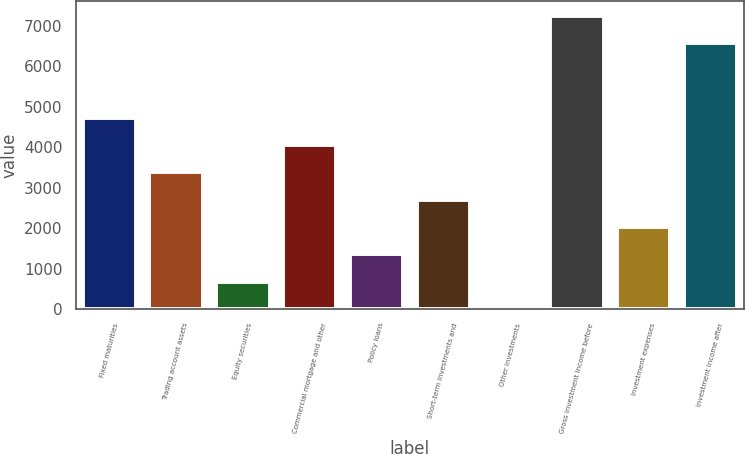<chart> <loc_0><loc_0><loc_500><loc_500><bar_chart><fcel>Fixed maturities<fcel>Trading account assets<fcel>Equity securities<fcel>Commercial mortgage and other<fcel>Policy loans<fcel>Short-term investments and<fcel>Other investments<fcel>Gross investment income before<fcel>Investment expenses<fcel>Investment income after<nl><fcel>4734.4<fcel>3382<fcel>677.2<fcel>4058.2<fcel>1353.4<fcel>2705.8<fcel>1<fcel>7251.2<fcel>2029.6<fcel>6575<nl></chart> 